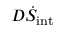Convert formula to latex. <formula><loc_0><loc_0><loc_500><loc_500>D \dot { S } _ { i n t }</formula> 